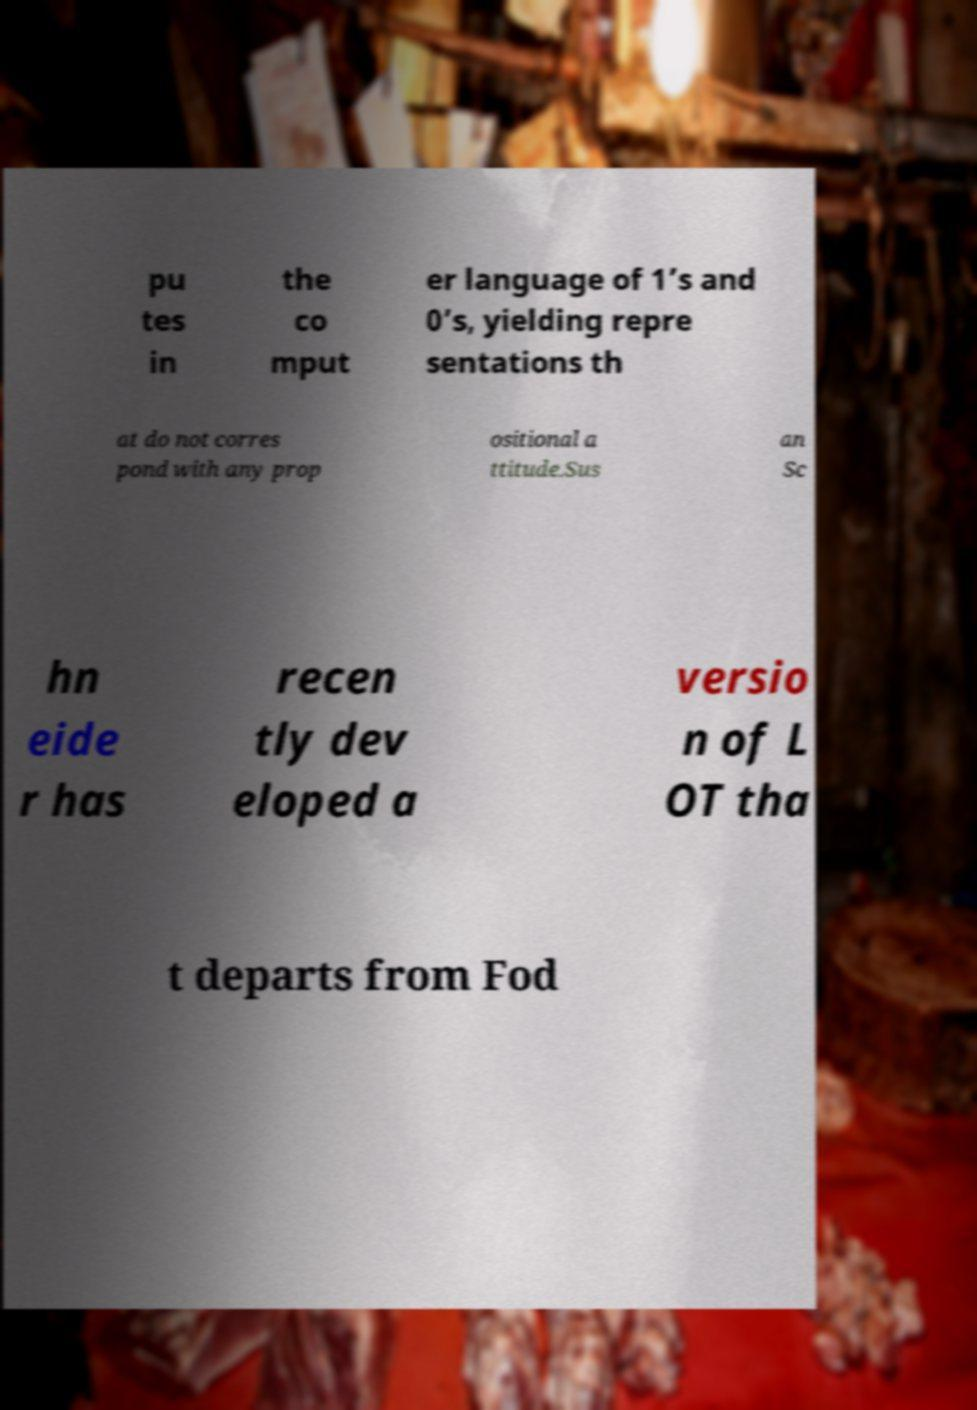Could you extract and type out the text from this image? pu tes in the co mput er language of 1’s and 0’s, yielding repre sentations th at do not corres pond with any prop ositional a ttitude.Sus an Sc hn eide r has recen tly dev eloped a versio n of L OT tha t departs from Fod 